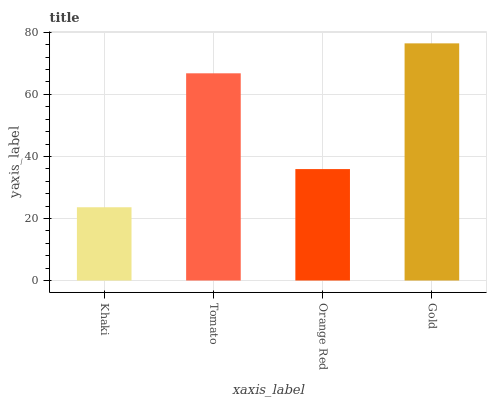Is Khaki the minimum?
Answer yes or no. Yes. Is Gold the maximum?
Answer yes or no. Yes. Is Tomato the minimum?
Answer yes or no. No. Is Tomato the maximum?
Answer yes or no. No. Is Tomato greater than Khaki?
Answer yes or no. Yes. Is Khaki less than Tomato?
Answer yes or no. Yes. Is Khaki greater than Tomato?
Answer yes or no. No. Is Tomato less than Khaki?
Answer yes or no. No. Is Tomato the high median?
Answer yes or no. Yes. Is Orange Red the low median?
Answer yes or no. Yes. Is Orange Red the high median?
Answer yes or no. No. Is Khaki the low median?
Answer yes or no. No. 